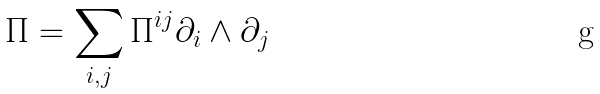Convert formula to latex. <formula><loc_0><loc_0><loc_500><loc_500>\Pi = \sum _ { i , j } \Pi ^ { i j } \partial _ { i } \wedge \partial _ { j }</formula> 